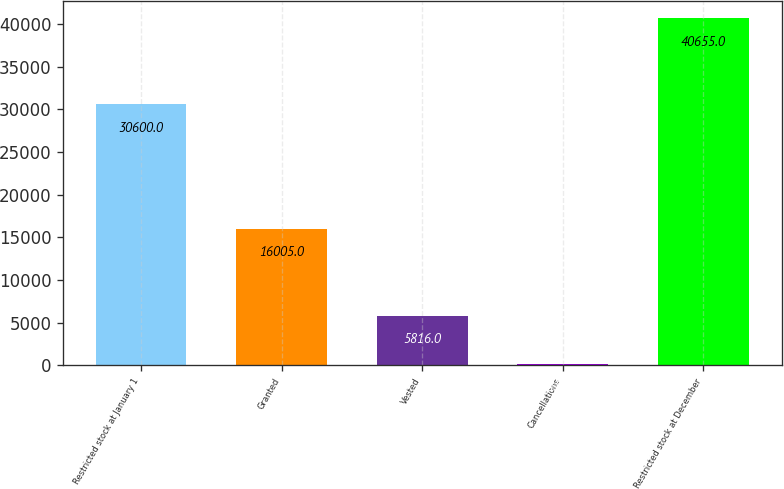Convert chart. <chart><loc_0><loc_0><loc_500><loc_500><bar_chart><fcel>Restricted stock at January 1<fcel>Granted<fcel>Vested<fcel>Cancellations<fcel>Restricted stock at December<nl><fcel>30600<fcel>16005<fcel>5816<fcel>134<fcel>40655<nl></chart> 